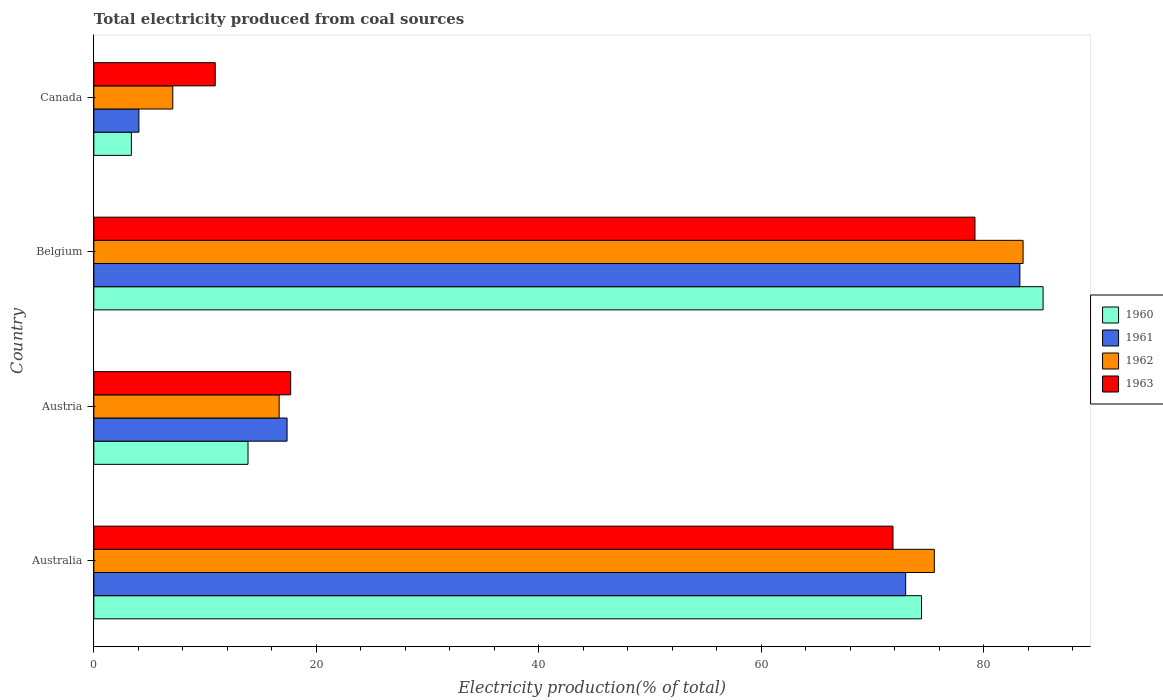How many bars are there on the 1st tick from the top?
Give a very brief answer. 4. In how many cases, is the number of bars for a given country not equal to the number of legend labels?
Your answer should be very brief. 0. What is the total electricity produced in 1961 in Australia?
Provide a succinct answer. 73. Across all countries, what is the maximum total electricity produced in 1961?
Give a very brief answer. 83.27. Across all countries, what is the minimum total electricity produced in 1963?
Your response must be concise. 10.92. In which country was the total electricity produced in 1961 maximum?
Ensure brevity in your answer.  Belgium. What is the total total electricity produced in 1961 in the graph?
Offer a very short reply. 177.7. What is the difference between the total electricity produced in 1960 in Austria and that in Belgium?
Offer a terse response. -71.49. What is the difference between the total electricity produced in 1962 in Austria and the total electricity produced in 1961 in Belgium?
Your response must be concise. -66.6. What is the average total electricity produced in 1961 per country?
Ensure brevity in your answer.  44.42. What is the difference between the total electricity produced in 1963 and total electricity produced in 1960 in Belgium?
Your answer should be compact. -6.12. What is the ratio of the total electricity produced in 1962 in Australia to that in Canada?
Make the answer very short. 10.65. Is the difference between the total electricity produced in 1963 in Australia and Austria greater than the difference between the total electricity produced in 1960 in Australia and Austria?
Your response must be concise. No. What is the difference between the highest and the second highest total electricity produced in 1963?
Your answer should be compact. 7.37. What is the difference between the highest and the lowest total electricity produced in 1962?
Offer a terse response. 76.46. What does the 2nd bar from the bottom in Canada represents?
Offer a very short reply. 1961. Is it the case that in every country, the sum of the total electricity produced in 1962 and total electricity produced in 1961 is greater than the total electricity produced in 1960?
Your answer should be compact. Yes. Are all the bars in the graph horizontal?
Provide a succinct answer. Yes. What is the difference between two consecutive major ticks on the X-axis?
Offer a very short reply. 20. Where does the legend appear in the graph?
Your response must be concise. Center right. What is the title of the graph?
Provide a short and direct response. Total electricity produced from coal sources. Does "1967" appear as one of the legend labels in the graph?
Your answer should be very brief. No. What is the label or title of the X-axis?
Provide a succinct answer. Electricity production(% of total). What is the Electricity production(% of total) in 1960 in Australia?
Make the answer very short. 74.42. What is the Electricity production(% of total) in 1961 in Australia?
Offer a terse response. 73. What is the Electricity production(% of total) of 1962 in Australia?
Give a very brief answer. 75.58. What is the Electricity production(% of total) of 1963 in Australia?
Your answer should be compact. 71.86. What is the Electricity production(% of total) of 1960 in Austria?
Provide a short and direct response. 13.86. What is the Electricity production(% of total) of 1961 in Austria?
Provide a short and direct response. 17.38. What is the Electricity production(% of total) of 1962 in Austria?
Offer a very short reply. 16.66. What is the Electricity production(% of total) of 1963 in Austria?
Provide a short and direct response. 17.7. What is the Electricity production(% of total) of 1960 in Belgium?
Offer a very short reply. 85.36. What is the Electricity production(% of total) in 1961 in Belgium?
Your answer should be very brief. 83.27. What is the Electricity production(% of total) in 1962 in Belgium?
Your response must be concise. 83.56. What is the Electricity production(% of total) of 1963 in Belgium?
Your answer should be very brief. 79.23. What is the Electricity production(% of total) in 1960 in Canada?
Provide a short and direct response. 3.38. What is the Electricity production(% of total) of 1961 in Canada?
Make the answer very short. 4.05. What is the Electricity production(% of total) of 1962 in Canada?
Give a very brief answer. 7.1. What is the Electricity production(% of total) of 1963 in Canada?
Give a very brief answer. 10.92. Across all countries, what is the maximum Electricity production(% of total) of 1960?
Make the answer very short. 85.36. Across all countries, what is the maximum Electricity production(% of total) in 1961?
Ensure brevity in your answer.  83.27. Across all countries, what is the maximum Electricity production(% of total) in 1962?
Provide a succinct answer. 83.56. Across all countries, what is the maximum Electricity production(% of total) of 1963?
Offer a terse response. 79.23. Across all countries, what is the minimum Electricity production(% of total) of 1960?
Your answer should be compact. 3.38. Across all countries, what is the minimum Electricity production(% of total) of 1961?
Make the answer very short. 4.05. Across all countries, what is the minimum Electricity production(% of total) of 1962?
Keep it short and to the point. 7.1. Across all countries, what is the minimum Electricity production(% of total) of 1963?
Provide a succinct answer. 10.92. What is the total Electricity production(% of total) in 1960 in the graph?
Offer a very short reply. 177.02. What is the total Electricity production(% of total) of 1961 in the graph?
Make the answer very short. 177.7. What is the total Electricity production(% of total) of 1962 in the graph?
Your answer should be compact. 182.9. What is the total Electricity production(% of total) of 1963 in the graph?
Keep it short and to the point. 179.71. What is the difference between the Electricity production(% of total) of 1960 in Australia and that in Austria?
Your answer should be compact. 60.56. What is the difference between the Electricity production(% of total) in 1961 in Australia and that in Austria?
Provide a short and direct response. 55.62. What is the difference between the Electricity production(% of total) of 1962 in Australia and that in Austria?
Offer a very short reply. 58.91. What is the difference between the Electricity production(% of total) of 1963 in Australia and that in Austria?
Offer a terse response. 54.16. What is the difference between the Electricity production(% of total) of 1960 in Australia and that in Belgium?
Your response must be concise. -10.93. What is the difference between the Electricity production(% of total) in 1961 in Australia and that in Belgium?
Provide a short and direct response. -10.27. What is the difference between the Electricity production(% of total) of 1962 in Australia and that in Belgium?
Ensure brevity in your answer.  -7.98. What is the difference between the Electricity production(% of total) in 1963 in Australia and that in Belgium?
Provide a short and direct response. -7.37. What is the difference between the Electricity production(% of total) in 1960 in Australia and that in Canada?
Ensure brevity in your answer.  71.05. What is the difference between the Electricity production(% of total) in 1961 in Australia and that in Canada?
Provide a short and direct response. 68.94. What is the difference between the Electricity production(% of total) in 1962 in Australia and that in Canada?
Make the answer very short. 68.48. What is the difference between the Electricity production(% of total) in 1963 in Australia and that in Canada?
Offer a terse response. 60.94. What is the difference between the Electricity production(% of total) in 1960 in Austria and that in Belgium?
Offer a terse response. -71.49. What is the difference between the Electricity production(% of total) in 1961 in Austria and that in Belgium?
Your answer should be very brief. -65.89. What is the difference between the Electricity production(% of total) in 1962 in Austria and that in Belgium?
Your response must be concise. -66.89. What is the difference between the Electricity production(% of total) in 1963 in Austria and that in Belgium?
Provide a short and direct response. -61.53. What is the difference between the Electricity production(% of total) in 1960 in Austria and that in Canada?
Ensure brevity in your answer.  10.49. What is the difference between the Electricity production(% of total) in 1961 in Austria and that in Canada?
Provide a short and direct response. 13.32. What is the difference between the Electricity production(% of total) in 1962 in Austria and that in Canada?
Keep it short and to the point. 9.57. What is the difference between the Electricity production(% of total) in 1963 in Austria and that in Canada?
Give a very brief answer. 6.79. What is the difference between the Electricity production(% of total) of 1960 in Belgium and that in Canada?
Your answer should be compact. 81.98. What is the difference between the Electricity production(% of total) in 1961 in Belgium and that in Canada?
Your answer should be very brief. 79.21. What is the difference between the Electricity production(% of total) in 1962 in Belgium and that in Canada?
Offer a terse response. 76.46. What is the difference between the Electricity production(% of total) of 1963 in Belgium and that in Canada?
Give a very brief answer. 68.31. What is the difference between the Electricity production(% of total) of 1960 in Australia and the Electricity production(% of total) of 1961 in Austria?
Keep it short and to the point. 57.05. What is the difference between the Electricity production(% of total) of 1960 in Australia and the Electricity production(% of total) of 1962 in Austria?
Your answer should be very brief. 57.76. What is the difference between the Electricity production(% of total) of 1960 in Australia and the Electricity production(% of total) of 1963 in Austria?
Ensure brevity in your answer.  56.72. What is the difference between the Electricity production(% of total) in 1961 in Australia and the Electricity production(% of total) in 1962 in Austria?
Ensure brevity in your answer.  56.33. What is the difference between the Electricity production(% of total) of 1961 in Australia and the Electricity production(% of total) of 1963 in Austria?
Give a very brief answer. 55.3. What is the difference between the Electricity production(% of total) in 1962 in Australia and the Electricity production(% of total) in 1963 in Austria?
Give a very brief answer. 57.87. What is the difference between the Electricity production(% of total) of 1960 in Australia and the Electricity production(% of total) of 1961 in Belgium?
Ensure brevity in your answer.  -8.84. What is the difference between the Electricity production(% of total) in 1960 in Australia and the Electricity production(% of total) in 1962 in Belgium?
Your response must be concise. -9.13. What is the difference between the Electricity production(% of total) of 1960 in Australia and the Electricity production(% of total) of 1963 in Belgium?
Offer a terse response. -4.81. What is the difference between the Electricity production(% of total) in 1961 in Australia and the Electricity production(% of total) in 1962 in Belgium?
Offer a terse response. -10.56. What is the difference between the Electricity production(% of total) in 1961 in Australia and the Electricity production(% of total) in 1963 in Belgium?
Offer a terse response. -6.23. What is the difference between the Electricity production(% of total) in 1962 in Australia and the Electricity production(% of total) in 1963 in Belgium?
Keep it short and to the point. -3.66. What is the difference between the Electricity production(% of total) of 1960 in Australia and the Electricity production(% of total) of 1961 in Canada?
Provide a short and direct response. 70.37. What is the difference between the Electricity production(% of total) in 1960 in Australia and the Electricity production(% of total) in 1962 in Canada?
Provide a short and direct response. 67.32. What is the difference between the Electricity production(% of total) in 1960 in Australia and the Electricity production(% of total) in 1963 in Canada?
Offer a very short reply. 63.51. What is the difference between the Electricity production(% of total) in 1961 in Australia and the Electricity production(% of total) in 1962 in Canada?
Give a very brief answer. 65.9. What is the difference between the Electricity production(% of total) in 1961 in Australia and the Electricity production(% of total) in 1963 in Canada?
Offer a very short reply. 62.08. What is the difference between the Electricity production(% of total) of 1962 in Australia and the Electricity production(% of total) of 1963 in Canada?
Make the answer very short. 64.66. What is the difference between the Electricity production(% of total) in 1960 in Austria and the Electricity production(% of total) in 1961 in Belgium?
Your answer should be compact. -69.4. What is the difference between the Electricity production(% of total) of 1960 in Austria and the Electricity production(% of total) of 1962 in Belgium?
Your answer should be compact. -69.69. What is the difference between the Electricity production(% of total) of 1960 in Austria and the Electricity production(% of total) of 1963 in Belgium?
Your answer should be compact. -65.37. What is the difference between the Electricity production(% of total) in 1961 in Austria and the Electricity production(% of total) in 1962 in Belgium?
Your answer should be compact. -66.18. What is the difference between the Electricity production(% of total) in 1961 in Austria and the Electricity production(% of total) in 1963 in Belgium?
Provide a succinct answer. -61.86. What is the difference between the Electricity production(% of total) in 1962 in Austria and the Electricity production(% of total) in 1963 in Belgium?
Make the answer very short. -62.57. What is the difference between the Electricity production(% of total) in 1960 in Austria and the Electricity production(% of total) in 1961 in Canada?
Provide a short and direct response. 9.81. What is the difference between the Electricity production(% of total) in 1960 in Austria and the Electricity production(% of total) in 1962 in Canada?
Your answer should be compact. 6.77. What is the difference between the Electricity production(% of total) of 1960 in Austria and the Electricity production(% of total) of 1963 in Canada?
Keep it short and to the point. 2.95. What is the difference between the Electricity production(% of total) in 1961 in Austria and the Electricity production(% of total) in 1962 in Canada?
Offer a very short reply. 10.28. What is the difference between the Electricity production(% of total) in 1961 in Austria and the Electricity production(% of total) in 1963 in Canada?
Ensure brevity in your answer.  6.46. What is the difference between the Electricity production(% of total) in 1962 in Austria and the Electricity production(% of total) in 1963 in Canada?
Give a very brief answer. 5.75. What is the difference between the Electricity production(% of total) in 1960 in Belgium and the Electricity production(% of total) in 1961 in Canada?
Give a very brief answer. 81.3. What is the difference between the Electricity production(% of total) in 1960 in Belgium and the Electricity production(% of total) in 1962 in Canada?
Your answer should be very brief. 78.26. What is the difference between the Electricity production(% of total) in 1960 in Belgium and the Electricity production(% of total) in 1963 in Canada?
Make the answer very short. 74.44. What is the difference between the Electricity production(% of total) in 1961 in Belgium and the Electricity production(% of total) in 1962 in Canada?
Provide a short and direct response. 76.17. What is the difference between the Electricity production(% of total) of 1961 in Belgium and the Electricity production(% of total) of 1963 in Canada?
Offer a terse response. 72.35. What is the difference between the Electricity production(% of total) in 1962 in Belgium and the Electricity production(% of total) in 1963 in Canada?
Offer a terse response. 72.64. What is the average Electricity production(% of total) in 1960 per country?
Your answer should be very brief. 44.26. What is the average Electricity production(% of total) of 1961 per country?
Give a very brief answer. 44.42. What is the average Electricity production(% of total) of 1962 per country?
Your answer should be compact. 45.72. What is the average Electricity production(% of total) in 1963 per country?
Give a very brief answer. 44.93. What is the difference between the Electricity production(% of total) of 1960 and Electricity production(% of total) of 1961 in Australia?
Offer a very short reply. 1.42. What is the difference between the Electricity production(% of total) of 1960 and Electricity production(% of total) of 1962 in Australia?
Provide a short and direct response. -1.15. What is the difference between the Electricity production(% of total) of 1960 and Electricity production(% of total) of 1963 in Australia?
Give a very brief answer. 2.57. What is the difference between the Electricity production(% of total) in 1961 and Electricity production(% of total) in 1962 in Australia?
Your response must be concise. -2.58. What is the difference between the Electricity production(% of total) of 1961 and Electricity production(% of total) of 1963 in Australia?
Offer a very short reply. 1.14. What is the difference between the Electricity production(% of total) of 1962 and Electricity production(% of total) of 1963 in Australia?
Ensure brevity in your answer.  3.72. What is the difference between the Electricity production(% of total) in 1960 and Electricity production(% of total) in 1961 in Austria?
Your answer should be compact. -3.51. What is the difference between the Electricity production(% of total) of 1960 and Electricity production(% of total) of 1962 in Austria?
Your answer should be very brief. -2.8. What is the difference between the Electricity production(% of total) in 1960 and Electricity production(% of total) in 1963 in Austria?
Ensure brevity in your answer.  -3.84. What is the difference between the Electricity production(% of total) of 1961 and Electricity production(% of total) of 1962 in Austria?
Provide a short and direct response. 0.71. What is the difference between the Electricity production(% of total) in 1961 and Electricity production(% of total) in 1963 in Austria?
Offer a very short reply. -0.33. What is the difference between the Electricity production(% of total) of 1962 and Electricity production(% of total) of 1963 in Austria?
Offer a very short reply. -1.04. What is the difference between the Electricity production(% of total) of 1960 and Electricity production(% of total) of 1961 in Belgium?
Offer a terse response. 2.09. What is the difference between the Electricity production(% of total) in 1960 and Electricity production(% of total) in 1962 in Belgium?
Offer a very short reply. 1.8. What is the difference between the Electricity production(% of total) in 1960 and Electricity production(% of total) in 1963 in Belgium?
Make the answer very short. 6.12. What is the difference between the Electricity production(% of total) in 1961 and Electricity production(% of total) in 1962 in Belgium?
Provide a succinct answer. -0.29. What is the difference between the Electricity production(% of total) in 1961 and Electricity production(% of total) in 1963 in Belgium?
Give a very brief answer. 4.04. What is the difference between the Electricity production(% of total) of 1962 and Electricity production(% of total) of 1963 in Belgium?
Provide a short and direct response. 4.33. What is the difference between the Electricity production(% of total) of 1960 and Electricity production(% of total) of 1961 in Canada?
Offer a very short reply. -0.68. What is the difference between the Electricity production(% of total) in 1960 and Electricity production(% of total) in 1962 in Canada?
Make the answer very short. -3.72. What is the difference between the Electricity production(% of total) in 1960 and Electricity production(% of total) in 1963 in Canada?
Ensure brevity in your answer.  -7.54. What is the difference between the Electricity production(% of total) of 1961 and Electricity production(% of total) of 1962 in Canada?
Provide a short and direct response. -3.04. What is the difference between the Electricity production(% of total) of 1961 and Electricity production(% of total) of 1963 in Canada?
Your answer should be compact. -6.86. What is the difference between the Electricity production(% of total) of 1962 and Electricity production(% of total) of 1963 in Canada?
Provide a short and direct response. -3.82. What is the ratio of the Electricity production(% of total) of 1960 in Australia to that in Austria?
Your answer should be very brief. 5.37. What is the ratio of the Electricity production(% of total) of 1961 in Australia to that in Austria?
Give a very brief answer. 4.2. What is the ratio of the Electricity production(% of total) in 1962 in Australia to that in Austria?
Offer a very short reply. 4.54. What is the ratio of the Electricity production(% of total) in 1963 in Australia to that in Austria?
Offer a terse response. 4.06. What is the ratio of the Electricity production(% of total) of 1960 in Australia to that in Belgium?
Give a very brief answer. 0.87. What is the ratio of the Electricity production(% of total) in 1961 in Australia to that in Belgium?
Provide a short and direct response. 0.88. What is the ratio of the Electricity production(% of total) of 1962 in Australia to that in Belgium?
Offer a very short reply. 0.9. What is the ratio of the Electricity production(% of total) in 1963 in Australia to that in Belgium?
Your answer should be compact. 0.91. What is the ratio of the Electricity production(% of total) of 1960 in Australia to that in Canada?
Your response must be concise. 22.03. What is the ratio of the Electricity production(% of total) of 1961 in Australia to that in Canada?
Provide a succinct answer. 18.01. What is the ratio of the Electricity production(% of total) of 1962 in Australia to that in Canada?
Your answer should be very brief. 10.65. What is the ratio of the Electricity production(% of total) in 1963 in Australia to that in Canada?
Provide a succinct answer. 6.58. What is the ratio of the Electricity production(% of total) in 1960 in Austria to that in Belgium?
Your answer should be compact. 0.16. What is the ratio of the Electricity production(% of total) of 1961 in Austria to that in Belgium?
Ensure brevity in your answer.  0.21. What is the ratio of the Electricity production(% of total) in 1962 in Austria to that in Belgium?
Make the answer very short. 0.2. What is the ratio of the Electricity production(% of total) of 1963 in Austria to that in Belgium?
Ensure brevity in your answer.  0.22. What is the ratio of the Electricity production(% of total) in 1960 in Austria to that in Canada?
Your answer should be very brief. 4.1. What is the ratio of the Electricity production(% of total) in 1961 in Austria to that in Canada?
Your response must be concise. 4.29. What is the ratio of the Electricity production(% of total) in 1962 in Austria to that in Canada?
Keep it short and to the point. 2.35. What is the ratio of the Electricity production(% of total) in 1963 in Austria to that in Canada?
Your response must be concise. 1.62. What is the ratio of the Electricity production(% of total) in 1960 in Belgium to that in Canada?
Provide a short and direct response. 25.27. What is the ratio of the Electricity production(% of total) of 1961 in Belgium to that in Canada?
Give a very brief answer. 20.54. What is the ratio of the Electricity production(% of total) of 1962 in Belgium to that in Canada?
Ensure brevity in your answer.  11.77. What is the ratio of the Electricity production(% of total) of 1963 in Belgium to that in Canada?
Your answer should be compact. 7.26. What is the difference between the highest and the second highest Electricity production(% of total) of 1960?
Keep it short and to the point. 10.93. What is the difference between the highest and the second highest Electricity production(% of total) of 1961?
Offer a terse response. 10.27. What is the difference between the highest and the second highest Electricity production(% of total) in 1962?
Your response must be concise. 7.98. What is the difference between the highest and the second highest Electricity production(% of total) of 1963?
Provide a succinct answer. 7.37. What is the difference between the highest and the lowest Electricity production(% of total) of 1960?
Give a very brief answer. 81.98. What is the difference between the highest and the lowest Electricity production(% of total) of 1961?
Offer a terse response. 79.21. What is the difference between the highest and the lowest Electricity production(% of total) of 1962?
Your response must be concise. 76.46. What is the difference between the highest and the lowest Electricity production(% of total) in 1963?
Your response must be concise. 68.31. 